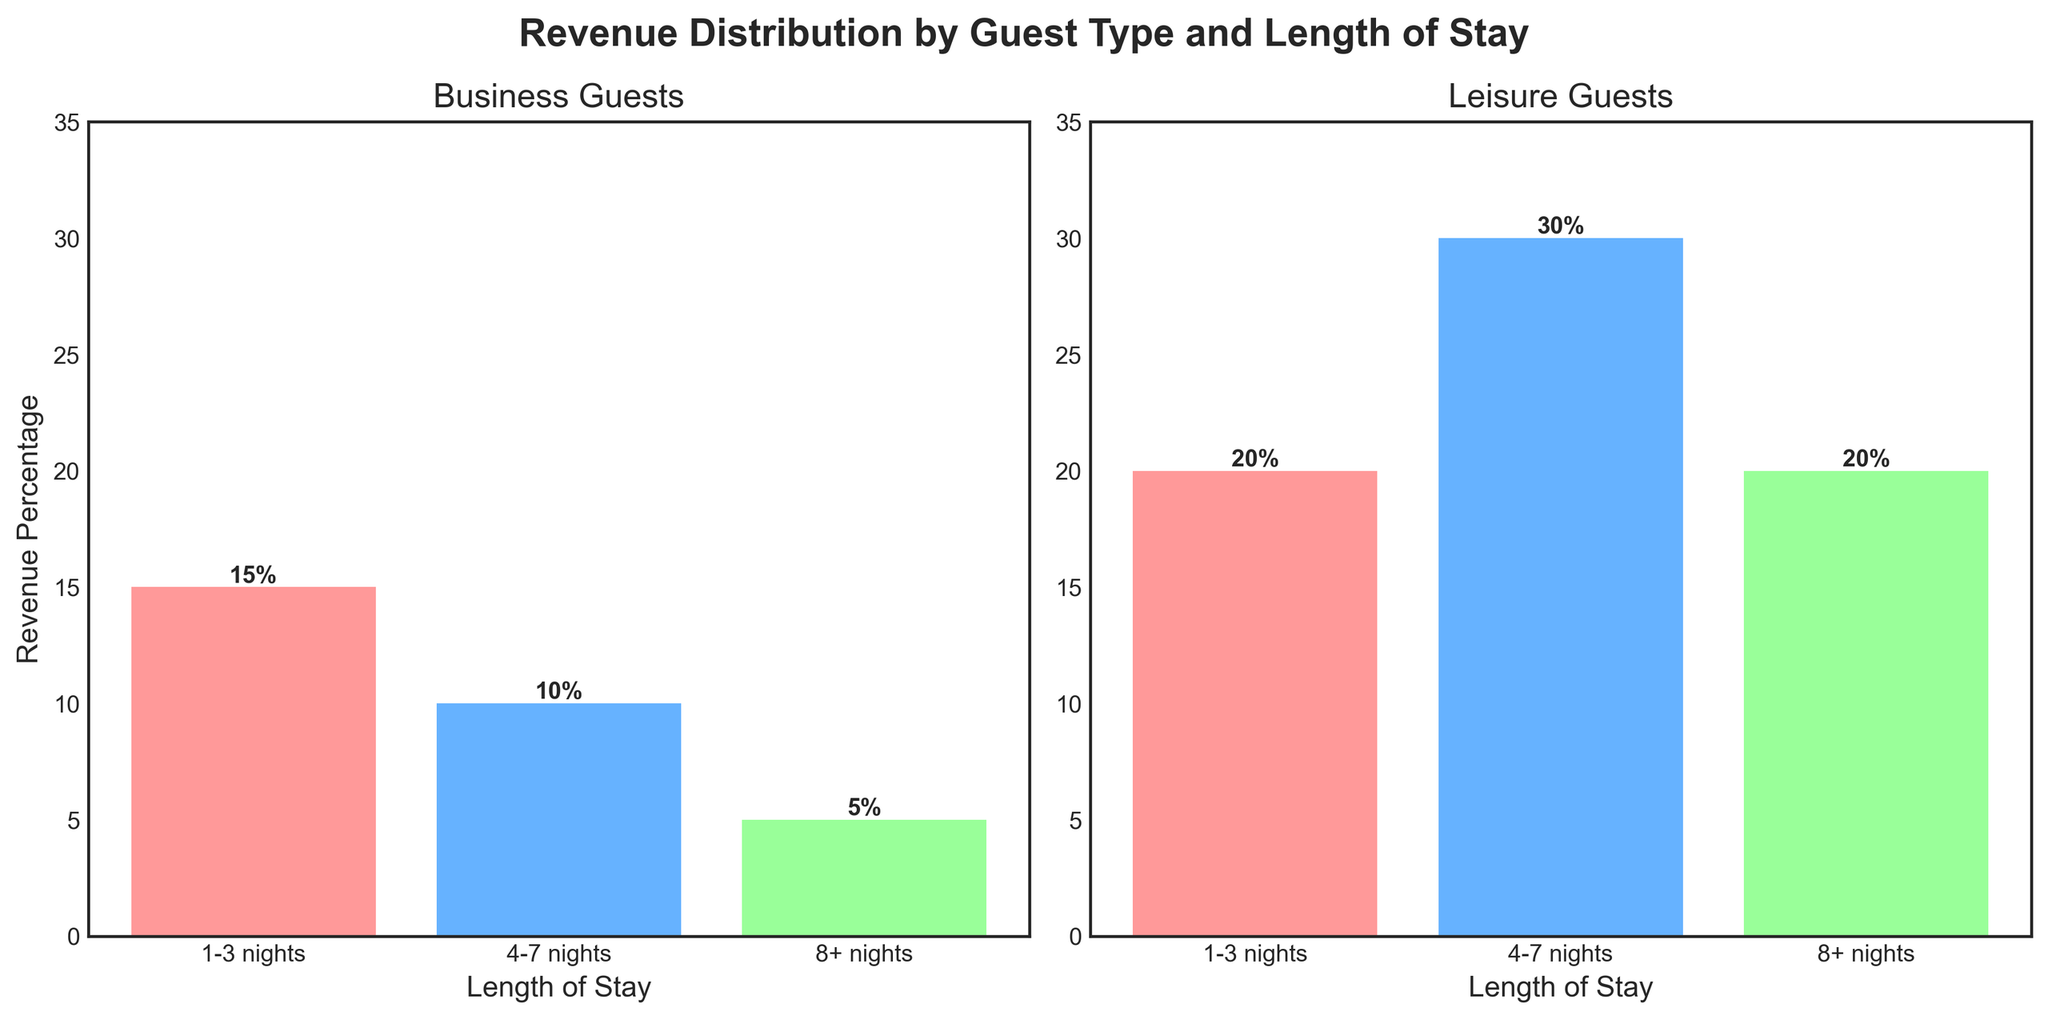How much higher is the revenue percentage for leisure guests staying 4-7 nights compared to business guests with the same length of stay? The revenue percentage for leisure guests staying 4-7 nights is 30%, while for business guests it's 10%. The difference is 30% - 10% = 20%.
Answer: 20% Which guest type generates higher revenue for stays of 1-3 nights? For 1-3 nights, business guests generate 15% revenue and leisure guests generate 20%. So, leisure guests generate higher revenue.
Answer: Leisure guests What's the total revenue percentage generated by business guests regardless of length of stay? Summing up the revenue percentages for business guests: 15% (1-3 nights) + 10% (4-7 nights) + 5% (8+ nights) = 30%.
Answer: 30% Which length of stay generates the highest revenue for leisure guests? For leisure guests, the revenue percentages are: 1-3 nights (20%), 4-7 nights (30%), and 8+ nights (20%). The highest revenue is from 4-7 nights at 30%.
Answer: 4-7 nights What is the average revenue percentage for leisure guests across all lengths of stay? The total revenue percentage is 20% (1-3 nights) + 30% (4-7 nights) + 20% (8+ nights) = 70%. The number of data points is 3. So, the average is 70% / 3 = 23.33%.
Answer: 23.33% Is there any category where the revenue percentage is the same for both guest types? For 8+ nights, both business guests and leisure guests generate the same revenue percentage of 20%.
Answer: Yes By how much does the revenue percentage for business guests staying 1-3 nights exceed those staying 8+ nights? The revenue percentage for business guests staying 1-3 nights is 15%, and for 8+ nights, it is 5%. The difference is 15% - 5% = 10%.
Answer: 10% What is the combined revenue percentage for leisure guests staying either 1-3 nights or 8+ nights? For leisure guests, the revenue for 1-3 nights is 20% and for 8+ nights is 20%. The combined revenue is 20% + 20% = 40%.
Answer: 40% Which color represents the revenue generated by business guests for 4-7 nights? The plot uses three colors for the length of stay: red (1-3 nights), blue (4-7 nights), and green (8+ nights). For 4-7 nights, the color used is blue.
Answer: Blue 